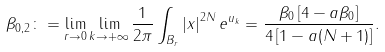Convert formula to latex. <formula><loc_0><loc_0><loc_500><loc_500>\beta _ { 0 , 2 } \colon = \lim _ { r \to 0 } \lim _ { k \to + \infty } \frac { 1 } { 2 \pi } \int _ { B _ { r } } \left | x \right | ^ { 2 N } e ^ { u _ { k } } = \frac { \beta _ { 0 } \left [ 4 - a \beta _ { 0 } \right ] } { 4 \left [ 1 - a ( N + 1 ) \right ] } .</formula> 